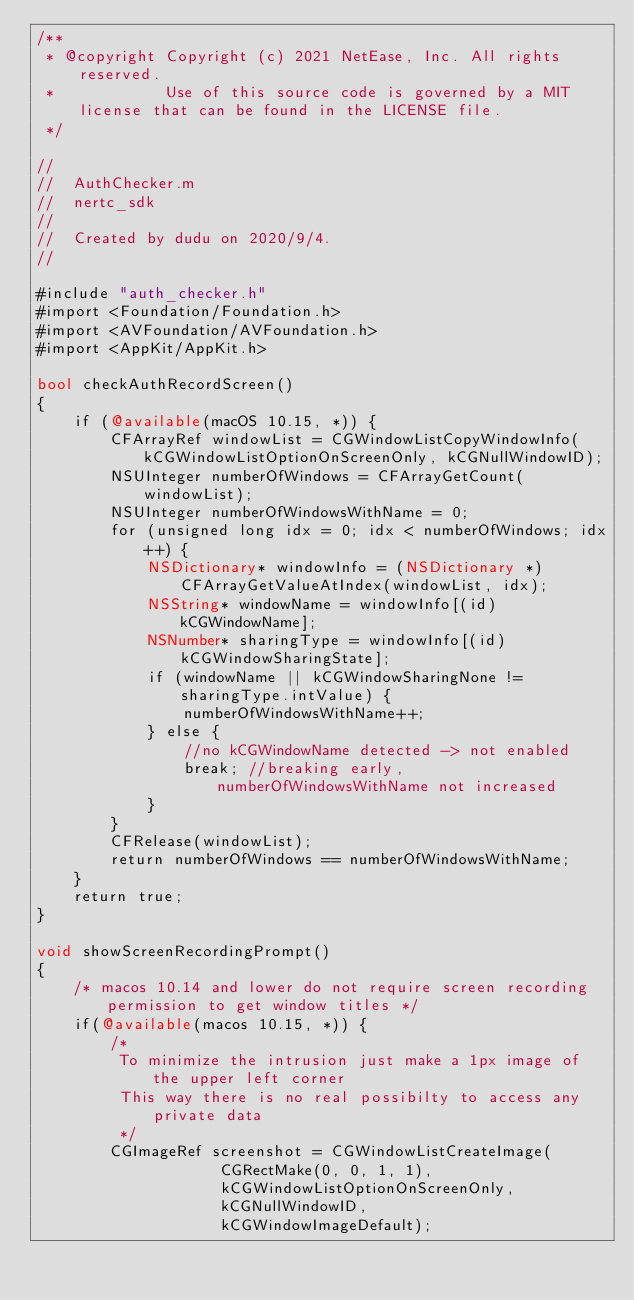Convert code to text. <code><loc_0><loc_0><loc_500><loc_500><_ObjectiveC_>/**
 * @copyright Copyright (c) 2021 NetEase, Inc. All rights reserved.
 *            Use of this source code is governed by a MIT license that can be found in the LICENSE file.
 */

//
//  AuthChecker.m
//  nertc_sdk
//
//  Created by dudu on 2020/9/4.
//

#include "auth_checker.h"
#import <Foundation/Foundation.h>
#import <AVFoundation/AVFoundation.h>
#import <AppKit/AppKit.h>

bool checkAuthRecordScreen()
{
    if (@available(macOS 10.15, *)) {
        CFArrayRef windowList = CGWindowListCopyWindowInfo(kCGWindowListOptionOnScreenOnly, kCGNullWindowID);
        NSUInteger numberOfWindows = CFArrayGetCount(windowList);
        NSUInteger numberOfWindowsWithName = 0;
        for (unsigned long idx = 0; idx < numberOfWindows; idx++) {
            NSDictionary* windowInfo = (NSDictionary *)CFArrayGetValueAtIndex(windowList, idx);
            NSString* windowName = windowInfo[(id)kCGWindowName];
            NSNumber* sharingType = windowInfo[(id)kCGWindowSharingState];
            if (windowName || kCGWindowSharingNone != sharingType.intValue) {
                numberOfWindowsWithName++;
            } else {
                //no kCGWindowName detected -> not enabled
                break; //breaking early, numberOfWindowsWithName not increased
            }
        }
        CFRelease(windowList);
        return numberOfWindows == numberOfWindowsWithName;
    }
    return true;
}

void showScreenRecordingPrompt()
{
    /* macos 10.14 and lower do not require screen recording permission to get window titles */
    if(@available(macos 10.15, *)) {
        /*
         To minimize the intrusion just make a 1px image of the upper left corner
         This way there is no real possibilty to access any private data
         */
        CGImageRef screenshot = CGWindowListCreateImage(
                    CGRectMake(0, 0, 1, 1),
                    kCGWindowListOptionOnScreenOnly,
                    kCGNullWindowID,
                    kCGWindowImageDefault);</code> 